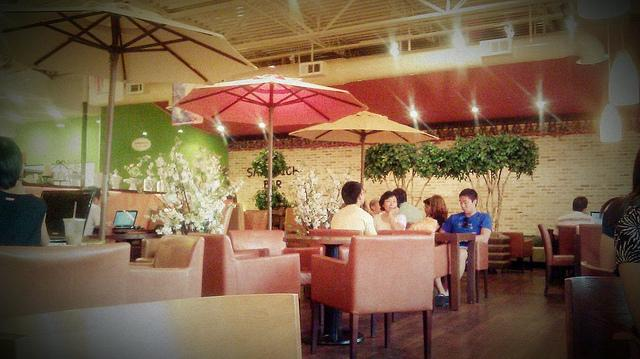What type of restaurant does this appear to be? chinese 